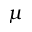Convert formula to latex. <formula><loc_0><loc_0><loc_500><loc_500>\mu</formula> 